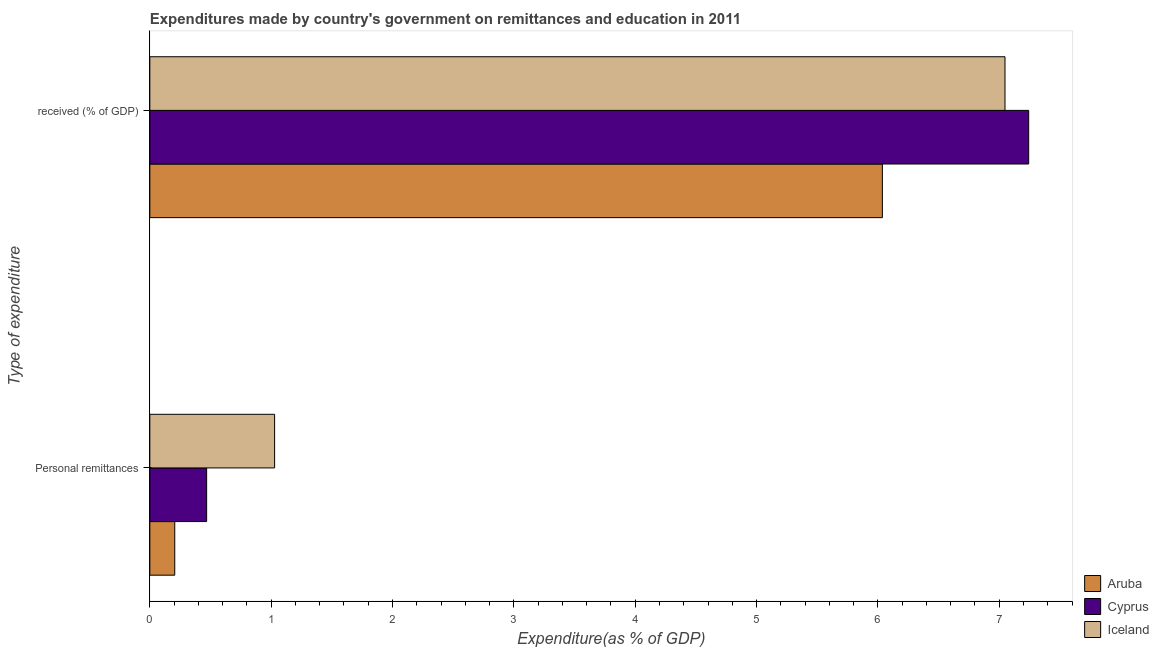How many different coloured bars are there?
Your answer should be compact. 3. How many groups of bars are there?
Give a very brief answer. 2. Are the number of bars per tick equal to the number of legend labels?
Offer a very short reply. Yes. Are the number of bars on each tick of the Y-axis equal?
Make the answer very short. Yes. How many bars are there on the 1st tick from the top?
Provide a short and direct response. 3. How many bars are there on the 1st tick from the bottom?
Your answer should be compact. 3. What is the label of the 1st group of bars from the top?
Make the answer very short.  received (% of GDP). What is the expenditure in education in Aruba?
Offer a terse response. 6.04. Across all countries, what is the maximum expenditure in education?
Provide a succinct answer. 7.24. Across all countries, what is the minimum expenditure in education?
Make the answer very short. 6.04. In which country was the expenditure in personal remittances maximum?
Offer a terse response. Iceland. In which country was the expenditure in personal remittances minimum?
Keep it short and to the point. Aruba. What is the total expenditure in education in the graph?
Offer a terse response. 20.33. What is the difference between the expenditure in education in Aruba and that in Iceland?
Provide a succinct answer. -1.01. What is the difference between the expenditure in education in Aruba and the expenditure in personal remittances in Iceland?
Your response must be concise. 5.01. What is the average expenditure in education per country?
Provide a succinct answer. 6.78. What is the difference between the expenditure in personal remittances and expenditure in education in Cyprus?
Offer a terse response. -6.77. What is the ratio of the expenditure in education in Aruba to that in Cyprus?
Make the answer very short. 0.83. In how many countries, is the expenditure in personal remittances greater than the average expenditure in personal remittances taken over all countries?
Ensure brevity in your answer.  1. What does the 3rd bar from the top in  received (% of GDP) represents?
Give a very brief answer. Aruba. What does the 1st bar from the bottom in  received (% of GDP) represents?
Ensure brevity in your answer.  Aruba. How many bars are there?
Give a very brief answer. 6. Where does the legend appear in the graph?
Provide a short and direct response. Bottom right. How are the legend labels stacked?
Provide a short and direct response. Vertical. What is the title of the graph?
Your response must be concise. Expenditures made by country's government on remittances and education in 2011. What is the label or title of the X-axis?
Ensure brevity in your answer.  Expenditure(as % of GDP). What is the label or title of the Y-axis?
Give a very brief answer. Type of expenditure. What is the Expenditure(as % of GDP) in Aruba in Personal remittances?
Provide a short and direct response. 0.21. What is the Expenditure(as % of GDP) of Cyprus in Personal remittances?
Your answer should be very brief. 0.47. What is the Expenditure(as % of GDP) of Iceland in Personal remittances?
Your answer should be compact. 1.03. What is the Expenditure(as % of GDP) in Aruba in  received (% of GDP)?
Provide a succinct answer. 6.04. What is the Expenditure(as % of GDP) in Cyprus in  received (% of GDP)?
Your response must be concise. 7.24. What is the Expenditure(as % of GDP) in Iceland in  received (% of GDP)?
Provide a succinct answer. 7.05. Across all Type of expenditure, what is the maximum Expenditure(as % of GDP) in Aruba?
Make the answer very short. 6.04. Across all Type of expenditure, what is the maximum Expenditure(as % of GDP) in Cyprus?
Your response must be concise. 7.24. Across all Type of expenditure, what is the maximum Expenditure(as % of GDP) in Iceland?
Your answer should be very brief. 7.05. Across all Type of expenditure, what is the minimum Expenditure(as % of GDP) of Aruba?
Your answer should be compact. 0.21. Across all Type of expenditure, what is the minimum Expenditure(as % of GDP) in Cyprus?
Ensure brevity in your answer.  0.47. Across all Type of expenditure, what is the minimum Expenditure(as % of GDP) in Iceland?
Provide a short and direct response. 1.03. What is the total Expenditure(as % of GDP) of Aruba in the graph?
Your answer should be compact. 6.24. What is the total Expenditure(as % of GDP) in Cyprus in the graph?
Your response must be concise. 7.71. What is the total Expenditure(as % of GDP) of Iceland in the graph?
Make the answer very short. 8.08. What is the difference between the Expenditure(as % of GDP) in Aruba in Personal remittances and that in  received (% of GDP)?
Offer a very short reply. -5.83. What is the difference between the Expenditure(as % of GDP) in Cyprus in Personal remittances and that in  received (% of GDP)?
Offer a terse response. -6.77. What is the difference between the Expenditure(as % of GDP) of Iceland in Personal remittances and that in  received (% of GDP)?
Ensure brevity in your answer.  -6.02. What is the difference between the Expenditure(as % of GDP) of Aruba in Personal remittances and the Expenditure(as % of GDP) of Cyprus in  received (% of GDP)?
Your response must be concise. -7.04. What is the difference between the Expenditure(as % of GDP) in Aruba in Personal remittances and the Expenditure(as % of GDP) in Iceland in  received (% of GDP)?
Your response must be concise. -6.84. What is the difference between the Expenditure(as % of GDP) in Cyprus in Personal remittances and the Expenditure(as % of GDP) in Iceland in  received (% of GDP)?
Give a very brief answer. -6.58. What is the average Expenditure(as % of GDP) in Aruba per Type of expenditure?
Provide a short and direct response. 3.12. What is the average Expenditure(as % of GDP) in Cyprus per Type of expenditure?
Provide a short and direct response. 3.86. What is the average Expenditure(as % of GDP) of Iceland per Type of expenditure?
Ensure brevity in your answer.  4.04. What is the difference between the Expenditure(as % of GDP) of Aruba and Expenditure(as % of GDP) of Cyprus in Personal remittances?
Your answer should be very brief. -0.26. What is the difference between the Expenditure(as % of GDP) of Aruba and Expenditure(as % of GDP) of Iceland in Personal remittances?
Offer a terse response. -0.82. What is the difference between the Expenditure(as % of GDP) in Cyprus and Expenditure(as % of GDP) in Iceland in Personal remittances?
Your response must be concise. -0.56. What is the difference between the Expenditure(as % of GDP) in Aruba and Expenditure(as % of GDP) in Cyprus in  received (% of GDP)?
Provide a short and direct response. -1.21. What is the difference between the Expenditure(as % of GDP) in Aruba and Expenditure(as % of GDP) in Iceland in  received (% of GDP)?
Give a very brief answer. -1.01. What is the difference between the Expenditure(as % of GDP) in Cyprus and Expenditure(as % of GDP) in Iceland in  received (% of GDP)?
Keep it short and to the point. 0.2. What is the ratio of the Expenditure(as % of GDP) in Aruba in Personal remittances to that in  received (% of GDP)?
Make the answer very short. 0.03. What is the ratio of the Expenditure(as % of GDP) of Cyprus in Personal remittances to that in  received (% of GDP)?
Give a very brief answer. 0.06. What is the ratio of the Expenditure(as % of GDP) in Iceland in Personal remittances to that in  received (% of GDP)?
Offer a terse response. 0.15. What is the difference between the highest and the second highest Expenditure(as % of GDP) of Aruba?
Ensure brevity in your answer.  5.83. What is the difference between the highest and the second highest Expenditure(as % of GDP) of Cyprus?
Your answer should be very brief. 6.77. What is the difference between the highest and the second highest Expenditure(as % of GDP) of Iceland?
Your answer should be compact. 6.02. What is the difference between the highest and the lowest Expenditure(as % of GDP) of Aruba?
Make the answer very short. 5.83. What is the difference between the highest and the lowest Expenditure(as % of GDP) in Cyprus?
Ensure brevity in your answer.  6.77. What is the difference between the highest and the lowest Expenditure(as % of GDP) of Iceland?
Keep it short and to the point. 6.02. 